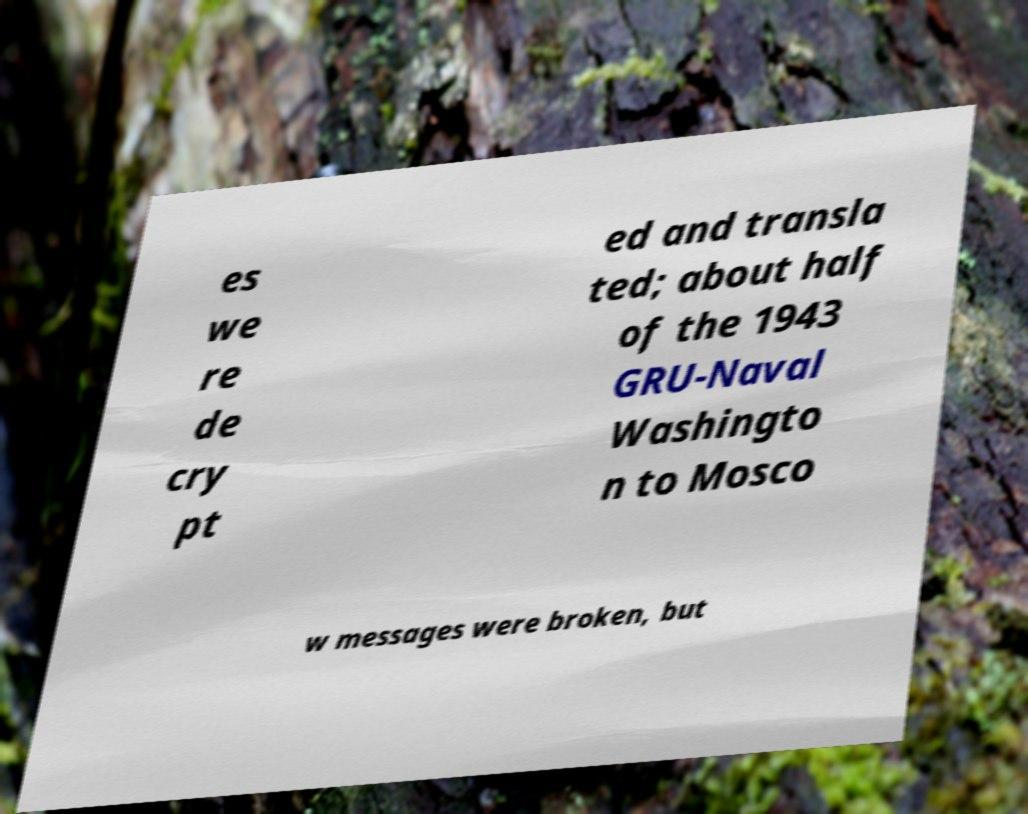Can you accurately transcribe the text from the provided image for me? es we re de cry pt ed and transla ted; about half of the 1943 GRU-Naval Washingto n to Mosco w messages were broken, but 